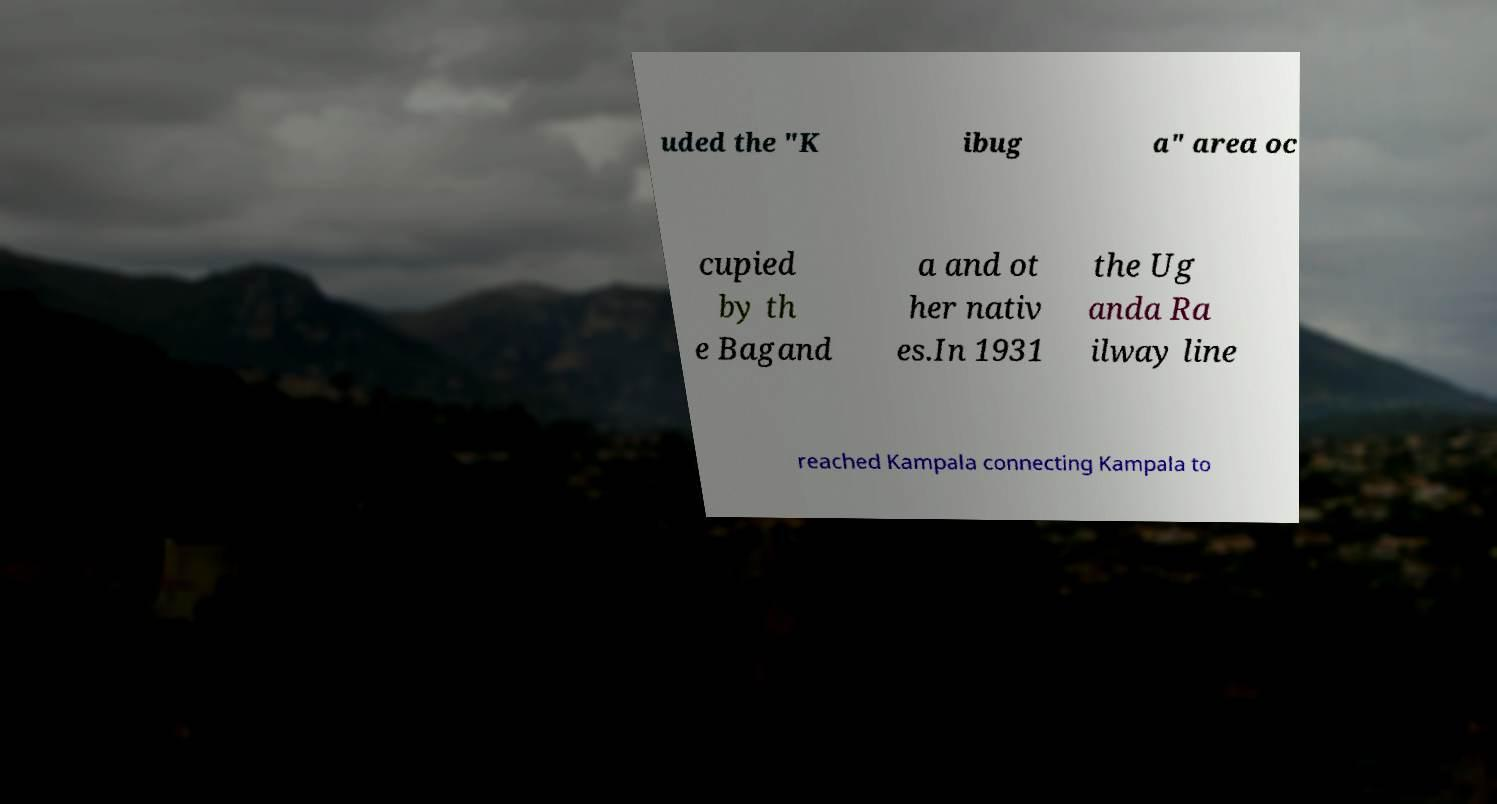Can you accurately transcribe the text from the provided image for me? uded the "K ibug a" area oc cupied by th e Bagand a and ot her nativ es.In 1931 the Ug anda Ra ilway line reached Kampala connecting Kampala to 